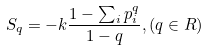Convert formula to latex. <formula><loc_0><loc_0><loc_500><loc_500>S _ { q } = - k \frac { 1 - \sum _ { i } p _ { i } ^ { q } } { 1 - q } , ( q \in R )</formula> 